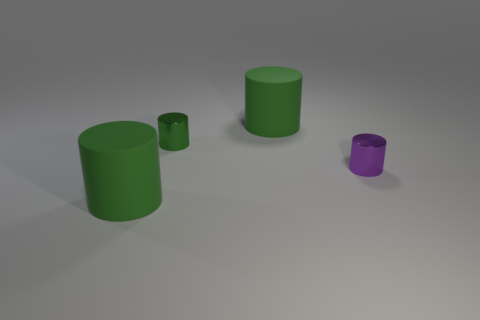How many other tiny purple cylinders have the same material as the purple cylinder?
Offer a terse response. 0. There is a thing that is both in front of the tiny green object and on the left side of the small purple metallic cylinder; what shape is it?
Make the answer very short. Cylinder. Is the large thing behind the purple object made of the same material as the tiny purple thing?
Give a very brief answer. No. There is a metal object that is the same size as the green metallic cylinder; what color is it?
Give a very brief answer. Purple. What number of other objects are the same size as the purple object?
Keep it short and to the point. 1. There is a large green cylinder in front of the purple cylinder; what material is it?
Keep it short and to the point. Rubber. There is a big green rubber thing in front of the large matte cylinder that is to the right of the shiny object behind the tiny purple shiny cylinder; what shape is it?
Your answer should be compact. Cylinder. How many things are either big green cylinders or things that are right of the small green object?
Provide a succinct answer. 3. How many objects are things that are left of the purple metallic cylinder or big objects on the right side of the green metal cylinder?
Provide a succinct answer. 3. Are there any tiny objects on the left side of the tiny green shiny cylinder?
Provide a succinct answer. No. 